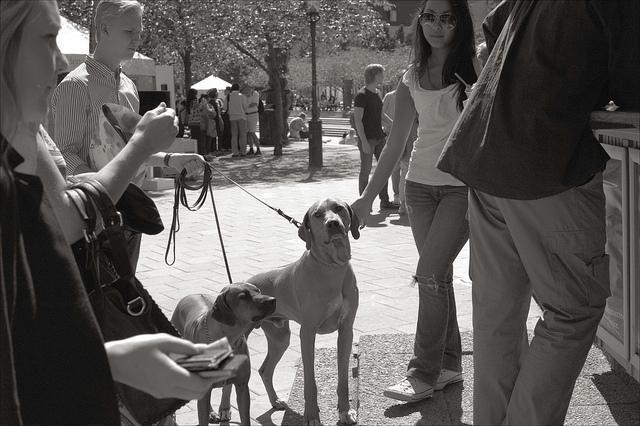How many dogs are held on the leashes?
Choose the correct response, then elucidate: 'Answer: answer
Rationale: rationale.'
Options: Three, two, one, four. Answer: two.
Rationale: There are two different dogs that are on leashes. 